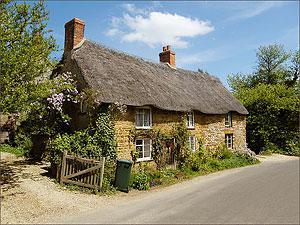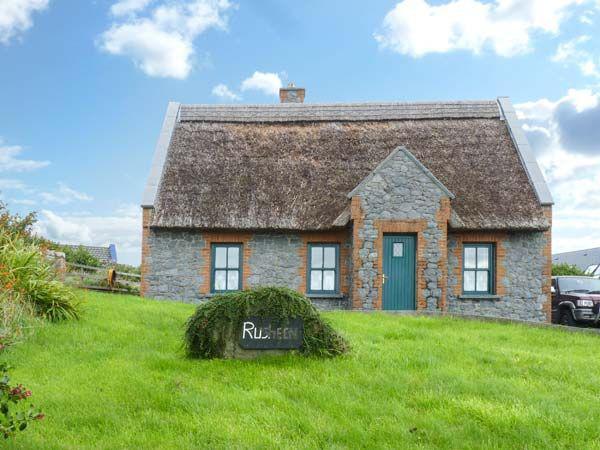The first image is the image on the left, the second image is the image on the right. Assess this claim about the two images: "The house in the left image has one chimney.". Correct or not? Answer yes or no. No. The first image is the image on the left, the second image is the image on the right. Considering the images on both sides, is "There are no fewer than 2 chimneys in the image on the left." valid? Answer yes or no. Yes. 